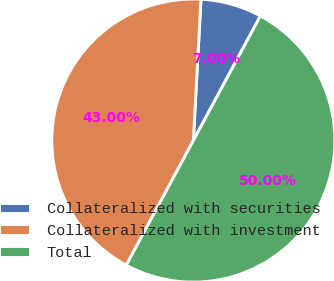Convert chart to OTSL. <chart><loc_0><loc_0><loc_500><loc_500><pie_chart><fcel>Collateralized with securities<fcel>Collateralized with investment<fcel>Total<nl><fcel>7.0%<fcel>43.0%<fcel>50.0%<nl></chart> 